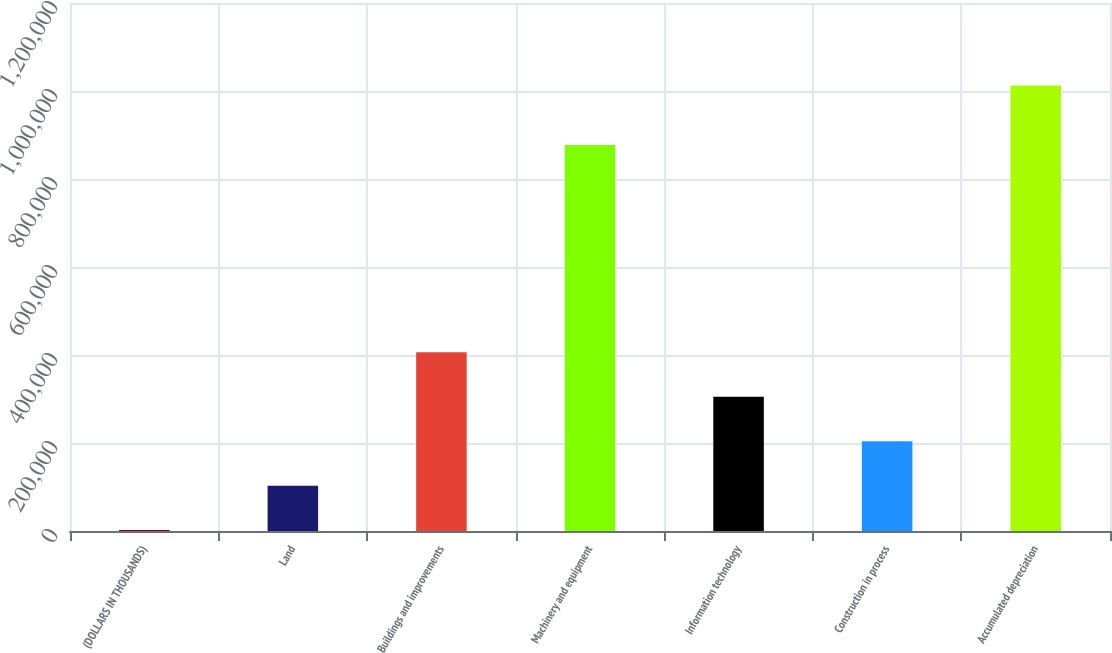Convert chart. <chart><loc_0><loc_0><loc_500><loc_500><bar_chart><fcel>(DOLLARS IN THOUSANDS)<fcel>Land<fcel>Buildings and improvements<fcel>Machinery and equipment<fcel>Information technology<fcel>Construction in process<fcel>Accumulated depreciation<nl><fcel>2012<fcel>103048<fcel>406158<fcel>877213<fcel>305121<fcel>204085<fcel>1.01238e+06<nl></chart> 